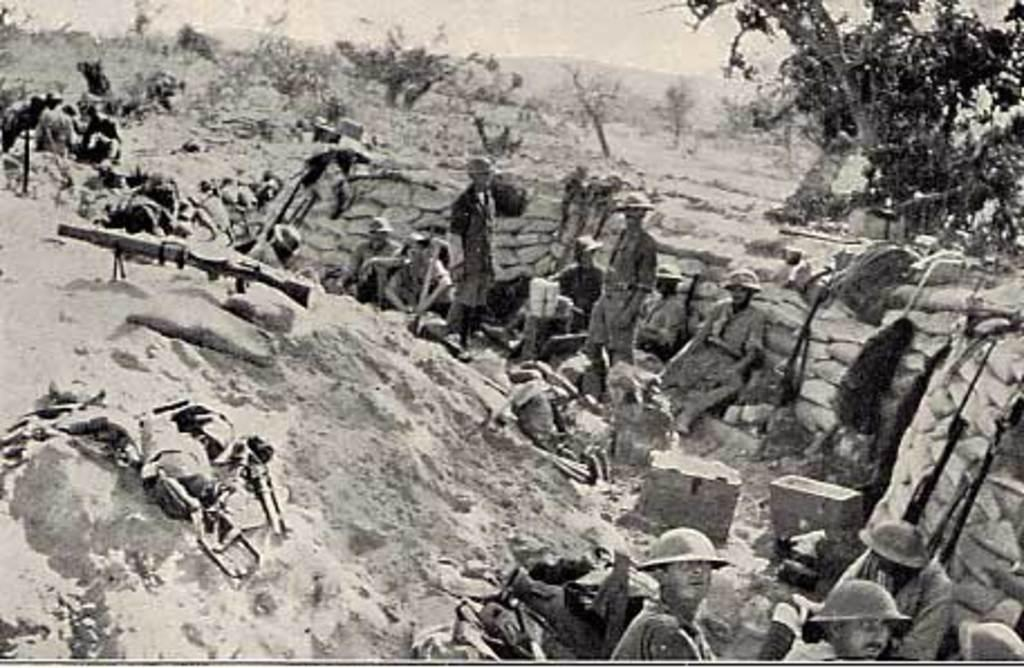What is the color scheme of the image? The image is black and white. What are the people in the image wearing? The people in the image are wearing uniforms. What can be seen in the hands of the people in the image? Guns are visible in the image. What might be used for carrying items in the image? Bags are present in the image. What other objects can be seen in the image? There are other objects in the image, but their specific details are not mentioned in the provided facts. What can be seen in the background of the image? Trees and rocks are visible in the background of the image. How many toes are visible on the people in the image? There is no information about the number of toes visible on the people in the image, as the focus is on their uniforms and the guns they are holding. --- Facts: 1. There is a car in the image. 2. The car is red. 3. The car has four wheels. 4. There are people in the car. 5. The car is parked on the street. 6. There are trees on the side of the street. Absurd Topics: fish, rainbow, volcano Conversation: What is the main subject of the image? The main subject of the image is a car. What color is the car? The car is red. How many wheels does the car have? The car has four wheels. Who or what is inside the car? There are people in the car. Where is the car located in the image? The car is parked on the street. What can be seen on the side of the street? There are trees on the side of the street. Reasoning: Let's think step by step in order to produce the conversation. We start by identifying the main subject of the image, which is the car. Then, we describe the car's color and the number of wheels it has. Next, we mention the presence of people inside the car. We also acknowledge the car's location, which is parked on the street. Finally, we describe the background of the image, which includes trees on the side of the street. Absurd Question/Answer: Can you see a fish swimming in the car in the image? No, there is no fish visible in the car or anywhere else in the image. --- Facts: 1. There is a person holding a book in the image. 2. The book is open. 3. The person is sitting on a chair. 4. There is a table next to the chair. 5. There is a lamp on the table. Absurd Topics: elephant, ocean, snow Conversation: 